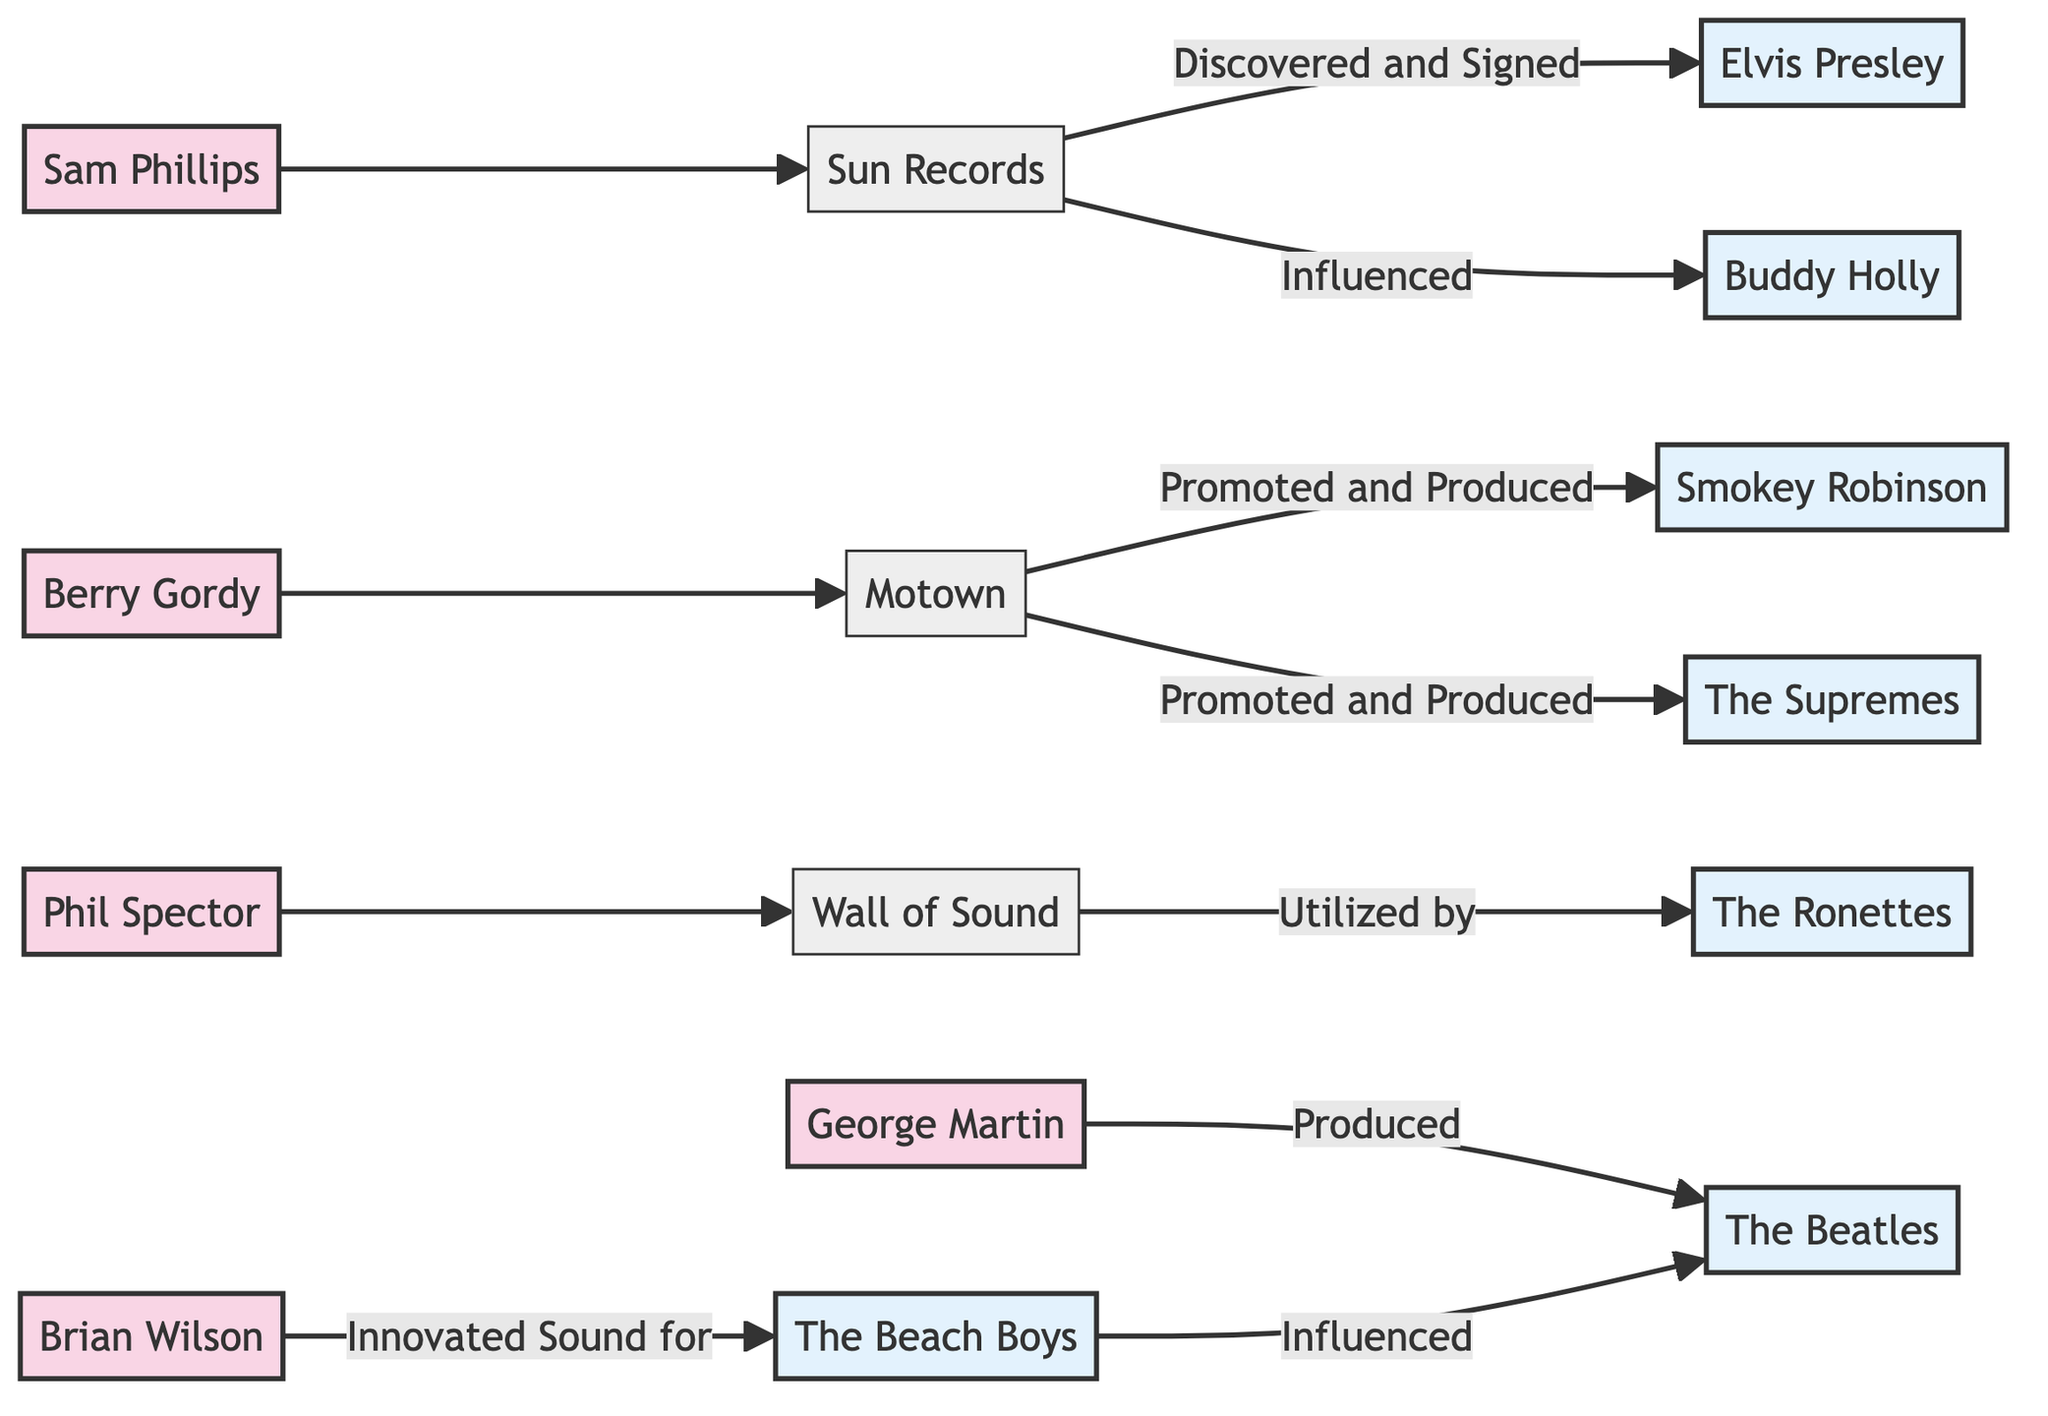What is the label of the edge between Sam Phillips and Sun Records? The diagram shows a directed edge from Sam Phillips to Sun Records without any special label, indicating a direct relationship. As represented in the diagram, the label does not exist; it simply connects the two nodes.
Answer: (no label) How many nodes are present in the diagram? By counting the unique entities listed in the nodes section, we find there are 15 nodes representing various artists, producers, and labels.
Answer: 15 Who was promoted and produced by Motown? Looking at the edges originating from the Motown node, both Smokey Robinson and The Supremes are mentioned specifically with the label "Promoted and Produced," which clearly indicates this relationship.
Answer: Smokey Robinson, The Supremes Which producer is linked to The Beatles? The edge from George Martin to The Beatles is labeled "Produced," indicating that George Martin has a direct relationship with The Beatles as their producer.
Answer: George Martin How many edges are there in total? Counting all the directed connections (edges) displayed in the diagram shows that there are 10 edges, which illustrate the various relationships between producers, artists, and labels.
Answer: 10 Which artist was discovered and signed by Sun Records? The directed edge from Sun Records to Elvis Presley has the label "Discovered and Signed," making it clear that Elvis Presley is linked to Sun Records in this context as an artist who was discovered.
Answer: Elvis Presley Which sound innovation is associated with Brian Wilson? The diagram indicates that Brian Wilson has a directed edge pointing to The Beach Boys with the label "Innovated Sound for," signifying that he is responsible for sound innovations associated with The Beach Boys.
Answer: The Beach Boys Which artists are influenced by The Beach Boys? The edge from The Beach Boys to The Beatles is labeled "Influenced," indicating that The Beatles were influenced by The Beach Boys, connecting the two in terms of musical impact.
Answer: The Beatles Which producer utilized the Wall of Sound technique? The directed edge from Phil Spector to Wall Of Sound signifies that Phil Spector is directly associated with this production technique, as stated in the labeling.
Answer: Phil Spector 